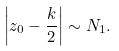Convert formula to latex. <formula><loc_0><loc_0><loc_500><loc_500>\left | z _ { 0 } - \frac { k } { 2 } \right | \sim N _ { 1 } .</formula> 